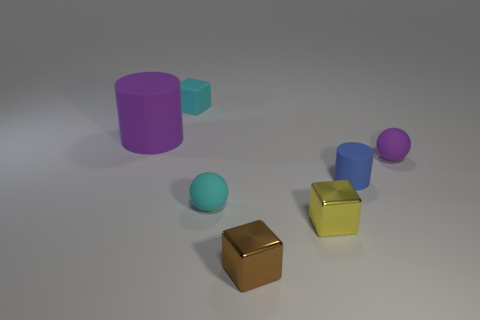What is the shape of the tiny purple thing?
Provide a short and direct response. Sphere. What material is the cylinder that is right of the cyan matte thing that is behind the thing to the left of the cyan rubber cube?
Ensure brevity in your answer.  Rubber. How many other things are there of the same material as the small brown block?
Your response must be concise. 1. What number of spheres are on the left side of the purple matte object that is to the right of the cyan block?
Keep it short and to the point. 1. How many balls are either tiny metallic things or tiny rubber objects?
Your answer should be compact. 2. What color is the tiny rubber thing that is both on the left side of the brown cube and right of the cyan matte cube?
Your response must be concise. Cyan. Are there any other things of the same color as the small rubber cylinder?
Offer a terse response. No. The small rubber object behind the cylinder that is left of the cyan rubber cube is what color?
Ensure brevity in your answer.  Cyan. Is the blue matte cylinder the same size as the brown metallic cube?
Your answer should be compact. Yes. Is the material of the cube to the left of the tiny brown shiny cube the same as the cylinder that is on the left side of the small matte cube?
Your answer should be very brief. Yes. 